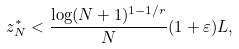Convert formula to latex. <formula><loc_0><loc_0><loc_500><loc_500>z _ { N } ^ { * } < \frac { \log ( N + 1 ) ^ { 1 - 1 / r } } { N } ( 1 + \varepsilon ) L ,</formula> 